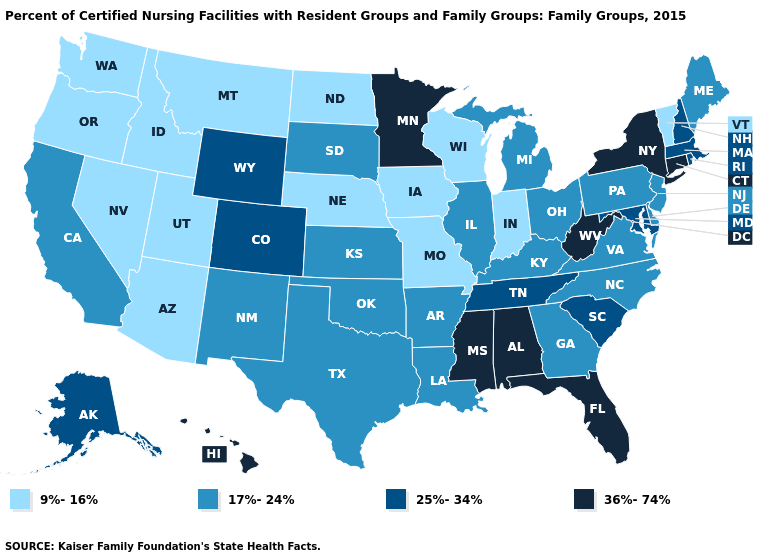Name the states that have a value in the range 36%-74%?
Quick response, please. Alabama, Connecticut, Florida, Hawaii, Minnesota, Mississippi, New York, West Virginia. Name the states that have a value in the range 25%-34%?
Concise answer only. Alaska, Colorado, Maryland, Massachusetts, New Hampshire, Rhode Island, South Carolina, Tennessee, Wyoming. Does Oregon have the lowest value in the USA?
Be succinct. Yes. What is the value of New Hampshire?
Answer briefly. 25%-34%. Does Utah have the lowest value in the USA?
Quick response, please. Yes. Among the states that border Idaho , does Wyoming have the lowest value?
Quick response, please. No. Does Oklahoma have the lowest value in the South?
Answer briefly. Yes. Does Minnesota have the highest value in the MidWest?
Quick response, please. Yes. What is the lowest value in the Northeast?
Give a very brief answer. 9%-16%. Which states have the lowest value in the USA?
Give a very brief answer. Arizona, Idaho, Indiana, Iowa, Missouri, Montana, Nebraska, Nevada, North Dakota, Oregon, Utah, Vermont, Washington, Wisconsin. Which states hav the highest value in the South?
Short answer required. Alabama, Florida, Mississippi, West Virginia. Does Alaska have a higher value than New Hampshire?
Write a very short answer. No. Which states have the lowest value in the USA?
Answer briefly. Arizona, Idaho, Indiana, Iowa, Missouri, Montana, Nebraska, Nevada, North Dakota, Oregon, Utah, Vermont, Washington, Wisconsin. Does Illinois have the lowest value in the MidWest?
Write a very short answer. No. Among the states that border Idaho , does Wyoming have the lowest value?
Short answer required. No. 